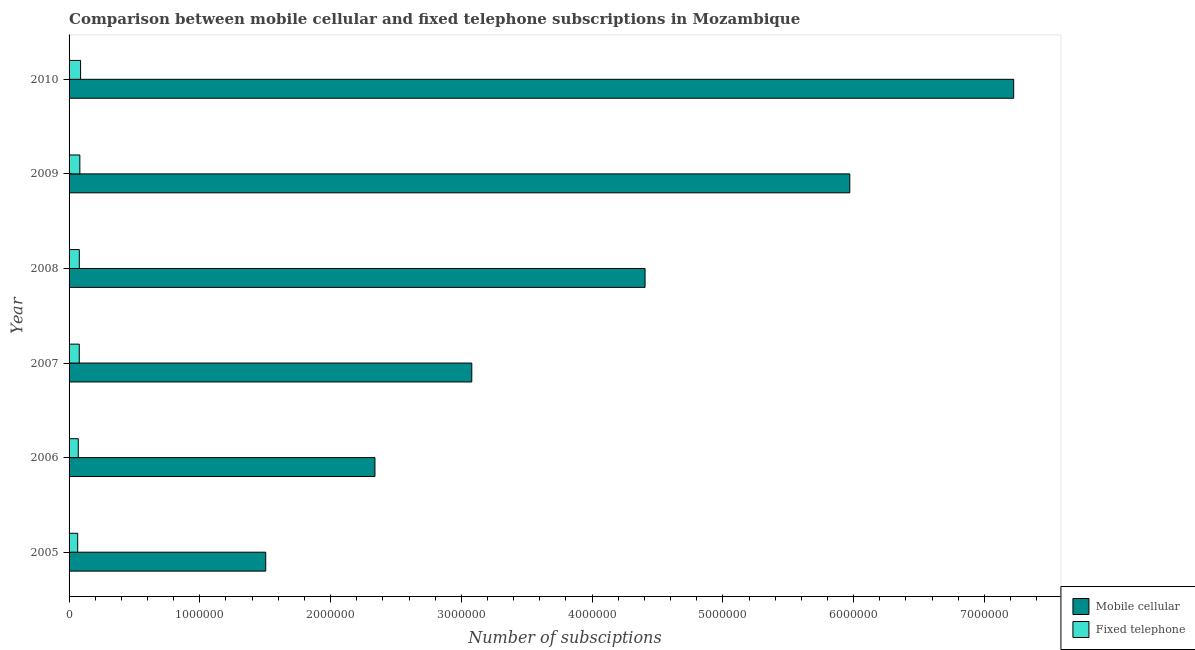Are the number of bars per tick equal to the number of legend labels?
Offer a terse response. Yes. Are the number of bars on each tick of the Y-axis equal?
Offer a very short reply. Yes. How many bars are there on the 4th tick from the top?
Provide a succinct answer. 2. What is the label of the 2nd group of bars from the top?
Offer a very short reply. 2009. What is the number of fixed telephone subscriptions in 2008?
Provide a short and direct response. 7.83e+04. Across all years, what is the maximum number of mobile cellular subscriptions?
Offer a very short reply. 7.22e+06. Across all years, what is the minimum number of mobile cellular subscriptions?
Provide a short and direct response. 1.50e+06. In which year was the number of fixed telephone subscriptions minimum?
Make the answer very short. 2005. What is the total number of mobile cellular subscriptions in the graph?
Your answer should be compact. 2.45e+07. What is the difference between the number of fixed telephone subscriptions in 2005 and that in 2006?
Keep it short and to the point. -4321. What is the difference between the number of mobile cellular subscriptions in 2006 and the number of fixed telephone subscriptions in 2005?
Provide a succinct answer. 2.27e+06. What is the average number of fixed telephone subscriptions per year?
Provide a short and direct response. 7.72e+04. In the year 2007, what is the difference between the number of fixed telephone subscriptions and number of mobile cellular subscriptions?
Provide a succinct answer. -3.00e+06. In how many years, is the number of fixed telephone subscriptions greater than 3600000 ?
Give a very brief answer. 0. What is the ratio of the number of fixed telephone subscriptions in 2006 to that in 2008?
Provide a short and direct response. 0.9. Is the number of mobile cellular subscriptions in 2006 less than that in 2008?
Make the answer very short. Yes. Is the difference between the number of fixed telephone subscriptions in 2006 and 2008 greater than the difference between the number of mobile cellular subscriptions in 2006 and 2008?
Provide a succinct answer. Yes. What is the difference between the highest and the second highest number of mobile cellular subscriptions?
Your answer should be compact. 1.25e+06. What is the difference between the highest and the lowest number of mobile cellular subscriptions?
Keep it short and to the point. 5.72e+06. Is the sum of the number of fixed telephone subscriptions in 2005 and 2006 greater than the maximum number of mobile cellular subscriptions across all years?
Ensure brevity in your answer.  No. What does the 1st bar from the top in 2005 represents?
Your answer should be compact. Fixed telephone. What does the 1st bar from the bottom in 2007 represents?
Provide a short and direct response. Mobile cellular. How many bars are there?
Give a very brief answer. 12. Are all the bars in the graph horizontal?
Your answer should be compact. Yes. How many years are there in the graph?
Provide a short and direct response. 6. What is the difference between two consecutive major ticks on the X-axis?
Your answer should be very brief. 1.00e+06. Where does the legend appear in the graph?
Your response must be concise. Bottom right. What is the title of the graph?
Make the answer very short. Comparison between mobile cellular and fixed telephone subscriptions in Mozambique. What is the label or title of the X-axis?
Keep it short and to the point. Number of subsciptions. What is the Number of subsciptions in Mobile cellular in 2005?
Make the answer very short. 1.50e+06. What is the Number of subsciptions of Fixed telephone in 2005?
Your response must be concise. 6.60e+04. What is the Number of subsciptions in Mobile cellular in 2006?
Ensure brevity in your answer.  2.34e+06. What is the Number of subsciptions in Fixed telephone in 2006?
Your answer should be very brief. 7.03e+04. What is the Number of subsciptions of Mobile cellular in 2007?
Provide a short and direct response. 3.08e+06. What is the Number of subsciptions in Fixed telephone in 2007?
Provide a short and direct response. 7.80e+04. What is the Number of subsciptions of Mobile cellular in 2008?
Ensure brevity in your answer.  4.41e+06. What is the Number of subsciptions of Fixed telephone in 2008?
Keep it short and to the point. 7.83e+04. What is the Number of subsciptions in Mobile cellular in 2009?
Offer a very short reply. 5.97e+06. What is the Number of subsciptions in Fixed telephone in 2009?
Provide a short and direct response. 8.24e+04. What is the Number of subsciptions in Mobile cellular in 2010?
Offer a terse response. 7.22e+06. What is the Number of subsciptions in Fixed telephone in 2010?
Give a very brief answer. 8.81e+04. Across all years, what is the maximum Number of subsciptions in Mobile cellular?
Ensure brevity in your answer.  7.22e+06. Across all years, what is the maximum Number of subsciptions in Fixed telephone?
Give a very brief answer. 8.81e+04. Across all years, what is the minimum Number of subsciptions in Mobile cellular?
Provide a succinct answer. 1.50e+06. Across all years, what is the minimum Number of subsciptions of Fixed telephone?
Your answer should be compact. 6.60e+04. What is the total Number of subsciptions of Mobile cellular in the graph?
Provide a succinct answer. 2.45e+07. What is the total Number of subsciptions of Fixed telephone in the graph?
Give a very brief answer. 4.63e+05. What is the difference between the Number of subsciptions in Mobile cellular in 2005 and that in 2006?
Your answer should be compact. -8.35e+05. What is the difference between the Number of subsciptions of Fixed telephone in 2005 and that in 2006?
Offer a terse response. -4321. What is the difference between the Number of subsciptions in Mobile cellular in 2005 and that in 2007?
Ensure brevity in your answer.  -1.58e+06. What is the difference between the Number of subsciptions in Fixed telephone in 2005 and that in 2007?
Give a very brief answer. -1.20e+04. What is the difference between the Number of subsciptions of Mobile cellular in 2005 and that in 2008?
Provide a short and direct response. -2.90e+06. What is the difference between the Number of subsciptions of Fixed telephone in 2005 and that in 2008?
Offer a very short reply. -1.23e+04. What is the difference between the Number of subsciptions in Mobile cellular in 2005 and that in 2009?
Your answer should be very brief. -4.47e+06. What is the difference between the Number of subsciptions of Fixed telephone in 2005 and that in 2009?
Provide a succinct answer. -1.65e+04. What is the difference between the Number of subsciptions of Mobile cellular in 2005 and that in 2010?
Keep it short and to the point. -5.72e+06. What is the difference between the Number of subsciptions in Fixed telephone in 2005 and that in 2010?
Provide a short and direct response. -2.21e+04. What is the difference between the Number of subsciptions of Mobile cellular in 2006 and that in 2007?
Provide a succinct answer. -7.40e+05. What is the difference between the Number of subsciptions of Fixed telephone in 2006 and that in 2007?
Provide a succinct answer. -7687. What is the difference between the Number of subsciptions in Mobile cellular in 2006 and that in 2008?
Your response must be concise. -2.07e+06. What is the difference between the Number of subsciptions in Fixed telephone in 2006 and that in 2008?
Ensure brevity in your answer.  -8011. What is the difference between the Number of subsciptions in Mobile cellular in 2006 and that in 2009?
Ensure brevity in your answer.  -3.63e+06. What is the difference between the Number of subsciptions in Fixed telephone in 2006 and that in 2009?
Your response must be concise. -1.21e+04. What is the difference between the Number of subsciptions of Mobile cellular in 2006 and that in 2010?
Your answer should be very brief. -4.88e+06. What is the difference between the Number of subsciptions in Fixed telephone in 2006 and that in 2010?
Ensure brevity in your answer.  -1.77e+04. What is the difference between the Number of subsciptions of Mobile cellular in 2007 and that in 2008?
Provide a short and direct response. -1.33e+06. What is the difference between the Number of subsciptions of Fixed telephone in 2007 and that in 2008?
Your response must be concise. -324. What is the difference between the Number of subsciptions in Mobile cellular in 2007 and that in 2009?
Your response must be concise. -2.89e+06. What is the difference between the Number of subsciptions of Fixed telephone in 2007 and that in 2009?
Make the answer very short. -4447. What is the difference between the Number of subsciptions of Mobile cellular in 2007 and that in 2010?
Your answer should be compact. -4.14e+06. What is the difference between the Number of subsciptions in Fixed telephone in 2007 and that in 2010?
Make the answer very short. -1.01e+04. What is the difference between the Number of subsciptions in Mobile cellular in 2008 and that in 2009?
Your answer should be compact. -1.57e+06. What is the difference between the Number of subsciptions in Fixed telephone in 2008 and that in 2009?
Your answer should be compact. -4123. What is the difference between the Number of subsciptions of Mobile cellular in 2008 and that in 2010?
Your answer should be very brief. -2.82e+06. What is the difference between the Number of subsciptions of Fixed telephone in 2008 and that in 2010?
Make the answer very short. -9738. What is the difference between the Number of subsciptions in Mobile cellular in 2009 and that in 2010?
Your answer should be very brief. -1.25e+06. What is the difference between the Number of subsciptions in Fixed telephone in 2009 and that in 2010?
Provide a succinct answer. -5615. What is the difference between the Number of subsciptions in Mobile cellular in 2005 and the Number of subsciptions in Fixed telephone in 2006?
Provide a succinct answer. 1.43e+06. What is the difference between the Number of subsciptions of Mobile cellular in 2005 and the Number of subsciptions of Fixed telephone in 2007?
Ensure brevity in your answer.  1.43e+06. What is the difference between the Number of subsciptions in Mobile cellular in 2005 and the Number of subsciptions in Fixed telephone in 2008?
Your answer should be very brief. 1.43e+06. What is the difference between the Number of subsciptions in Mobile cellular in 2005 and the Number of subsciptions in Fixed telephone in 2009?
Your response must be concise. 1.42e+06. What is the difference between the Number of subsciptions in Mobile cellular in 2005 and the Number of subsciptions in Fixed telephone in 2010?
Offer a very short reply. 1.42e+06. What is the difference between the Number of subsciptions in Mobile cellular in 2006 and the Number of subsciptions in Fixed telephone in 2007?
Offer a very short reply. 2.26e+06. What is the difference between the Number of subsciptions of Mobile cellular in 2006 and the Number of subsciptions of Fixed telephone in 2008?
Ensure brevity in your answer.  2.26e+06. What is the difference between the Number of subsciptions of Mobile cellular in 2006 and the Number of subsciptions of Fixed telephone in 2009?
Your answer should be very brief. 2.26e+06. What is the difference between the Number of subsciptions in Mobile cellular in 2006 and the Number of subsciptions in Fixed telephone in 2010?
Give a very brief answer. 2.25e+06. What is the difference between the Number of subsciptions in Mobile cellular in 2007 and the Number of subsciptions in Fixed telephone in 2008?
Provide a short and direct response. 3.00e+06. What is the difference between the Number of subsciptions of Mobile cellular in 2007 and the Number of subsciptions of Fixed telephone in 2009?
Keep it short and to the point. 3.00e+06. What is the difference between the Number of subsciptions in Mobile cellular in 2007 and the Number of subsciptions in Fixed telephone in 2010?
Your response must be concise. 2.99e+06. What is the difference between the Number of subsciptions in Mobile cellular in 2008 and the Number of subsciptions in Fixed telephone in 2009?
Offer a terse response. 4.32e+06. What is the difference between the Number of subsciptions of Mobile cellular in 2008 and the Number of subsciptions of Fixed telephone in 2010?
Provide a short and direct response. 4.32e+06. What is the difference between the Number of subsciptions of Mobile cellular in 2009 and the Number of subsciptions of Fixed telephone in 2010?
Your answer should be compact. 5.88e+06. What is the average Number of subsciptions in Mobile cellular per year?
Provide a succinct answer. 4.09e+06. What is the average Number of subsciptions in Fixed telephone per year?
Offer a terse response. 7.72e+04. In the year 2005, what is the difference between the Number of subsciptions in Mobile cellular and Number of subsciptions in Fixed telephone?
Your answer should be very brief. 1.44e+06. In the year 2006, what is the difference between the Number of subsciptions of Mobile cellular and Number of subsciptions of Fixed telephone?
Provide a short and direct response. 2.27e+06. In the year 2007, what is the difference between the Number of subsciptions in Mobile cellular and Number of subsciptions in Fixed telephone?
Give a very brief answer. 3.00e+06. In the year 2008, what is the difference between the Number of subsciptions in Mobile cellular and Number of subsciptions in Fixed telephone?
Your response must be concise. 4.33e+06. In the year 2009, what is the difference between the Number of subsciptions of Mobile cellular and Number of subsciptions of Fixed telephone?
Ensure brevity in your answer.  5.89e+06. In the year 2010, what is the difference between the Number of subsciptions of Mobile cellular and Number of subsciptions of Fixed telephone?
Offer a terse response. 7.14e+06. What is the ratio of the Number of subsciptions in Mobile cellular in 2005 to that in 2006?
Your answer should be very brief. 0.64. What is the ratio of the Number of subsciptions of Fixed telephone in 2005 to that in 2006?
Your answer should be very brief. 0.94. What is the ratio of the Number of subsciptions of Mobile cellular in 2005 to that in 2007?
Offer a terse response. 0.49. What is the ratio of the Number of subsciptions in Fixed telephone in 2005 to that in 2007?
Keep it short and to the point. 0.85. What is the ratio of the Number of subsciptions in Mobile cellular in 2005 to that in 2008?
Ensure brevity in your answer.  0.34. What is the ratio of the Number of subsciptions in Fixed telephone in 2005 to that in 2008?
Provide a short and direct response. 0.84. What is the ratio of the Number of subsciptions of Mobile cellular in 2005 to that in 2009?
Provide a succinct answer. 0.25. What is the ratio of the Number of subsciptions of Fixed telephone in 2005 to that in 2009?
Your answer should be compact. 0.8. What is the ratio of the Number of subsciptions in Mobile cellular in 2005 to that in 2010?
Offer a very short reply. 0.21. What is the ratio of the Number of subsciptions in Fixed telephone in 2005 to that in 2010?
Provide a succinct answer. 0.75. What is the ratio of the Number of subsciptions of Mobile cellular in 2006 to that in 2007?
Give a very brief answer. 0.76. What is the ratio of the Number of subsciptions in Fixed telephone in 2006 to that in 2007?
Offer a terse response. 0.9. What is the ratio of the Number of subsciptions in Mobile cellular in 2006 to that in 2008?
Your response must be concise. 0.53. What is the ratio of the Number of subsciptions in Fixed telephone in 2006 to that in 2008?
Ensure brevity in your answer.  0.9. What is the ratio of the Number of subsciptions of Mobile cellular in 2006 to that in 2009?
Offer a terse response. 0.39. What is the ratio of the Number of subsciptions in Fixed telephone in 2006 to that in 2009?
Give a very brief answer. 0.85. What is the ratio of the Number of subsciptions of Mobile cellular in 2006 to that in 2010?
Make the answer very short. 0.32. What is the ratio of the Number of subsciptions of Fixed telephone in 2006 to that in 2010?
Keep it short and to the point. 0.8. What is the ratio of the Number of subsciptions in Mobile cellular in 2007 to that in 2008?
Your response must be concise. 0.7. What is the ratio of the Number of subsciptions of Fixed telephone in 2007 to that in 2008?
Provide a short and direct response. 1. What is the ratio of the Number of subsciptions of Mobile cellular in 2007 to that in 2009?
Keep it short and to the point. 0.52. What is the ratio of the Number of subsciptions of Fixed telephone in 2007 to that in 2009?
Give a very brief answer. 0.95. What is the ratio of the Number of subsciptions in Mobile cellular in 2007 to that in 2010?
Give a very brief answer. 0.43. What is the ratio of the Number of subsciptions in Fixed telephone in 2007 to that in 2010?
Your answer should be very brief. 0.89. What is the ratio of the Number of subsciptions in Mobile cellular in 2008 to that in 2009?
Give a very brief answer. 0.74. What is the ratio of the Number of subsciptions in Mobile cellular in 2008 to that in 2010?
Offer a very short reply. 0.61. What is the ratio of the Number of subsciptions of Fixed telephone in 2008 to that in 2010?
Provide a short and direct response. 0.89. What is the ratio of the Number of subsciptions in Mobile cellular in 2009 to that in 2010?
Your response must be concise. 0.83. What is the ratio of the Number of subsciptions in Fixed telephone in 2009 to that in 2010?
Offer a terse response. 0.94. What is the difference between the highest and the second highest Number of subsciptions in Mobile cellular?
Your answer should be very brief. 1.25e+06. What is the difference between the highest and the second highest Number of subsciptions of Fixed telephone?
Make the answer very short. 5615. What is the difference between the highest and the lowest Number of subsciptions in Mobile cellular?
Give a very brief answer. 5.72e+06. What is the difference between the highest and the lowest Number of subsciptions of Fixed telephone?
Make the answer very short. 2.21e+04. 